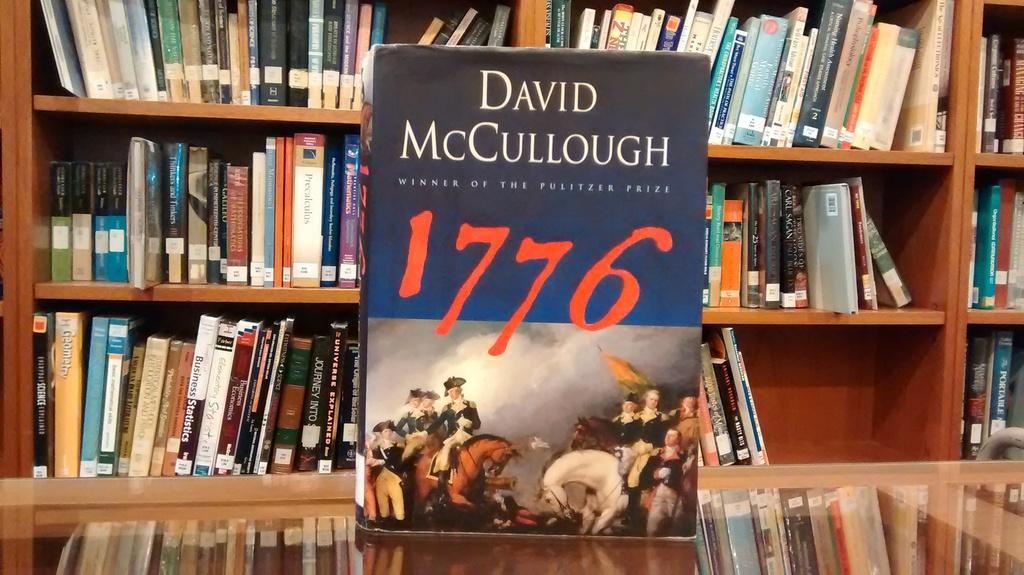Could you give a brief overview of what you see in this image? In the middle of the picture, we see a book. This book might be placed on the glass table. In the background, we see a rack in which many books are placed. This picture might be clicked in the library. 